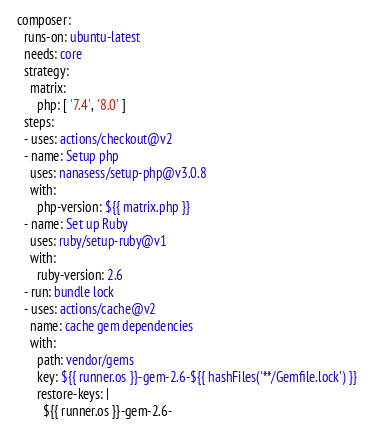Convert code to text. <code><loc_0><loc_0><loc_500><loc_500><_YAML_>  composer:
    runs-on: ubuntu-latest
    needs: core
    strategy:
      matrix:
        php: [ '7.4', '8.0' ]
    steps:
    - uses: actions/checkout@v2
    - name: Setup php
      uses: nanasess/setup-php@v3.0.8
      with:
        php-version: ${{ matrix.php }}
    - name: Set up Ruby
      uses: ruby/setup-ruby@v1
      with:
        ruby-version: 2.6
    - run: bundle lock
    - uses: actions/cache@v2
      name: cache gem dependencies
      with:
        path: vendor/gems
        key: ${{ runner.os }}-gem-2.6-${{ hashFiles('**/Gemfile.lock') }}
        restore-keys: |
          ${{ runner.os }}-gem-2.6-</code> 